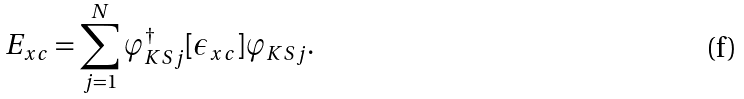Convert formula to latex. <formula><loc_0><loc_0><loc_500><loc_500>E _ { x c } = \sum _ { j = 1 } ^ { N } \varphi _ { K S j } ^ { \dagger } [ \epsilon _ { x c } ] \varphi _ { K S j } .</formula> 